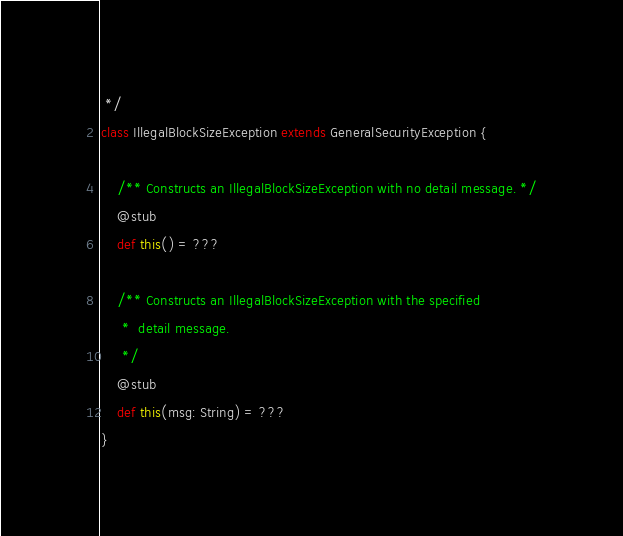Convert code to text. <code><loc_0><loc_0><loc_500><loc_500><_Scala_> */
class IllegalBlockSizeException extends GeneralSecurityException {

    /** Constructs an IllegalBlockSizeException with no detail message. */
    @stub
    def this() = ???

    /** Constructs an IllegalBlockSizeException with the specified
     *  detail message.
     */
    @stub
    def this(msg: String) = ???
}
</code> 